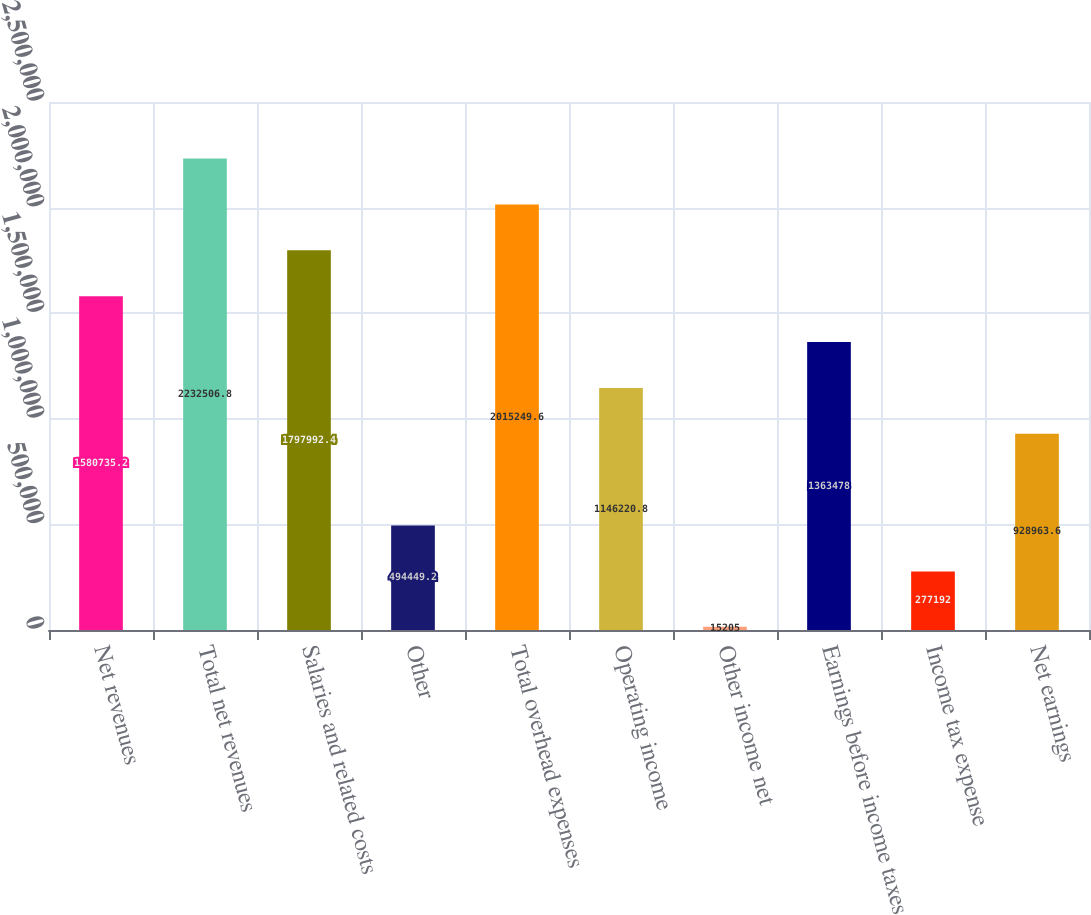Convert chart to OTSL. <chart><loc_0><loc_0><loc_500><loc_500><bar_chart><fcel>Net revenues<fcel>Total net revenues<fcel>Salaries and related costs<fcel>Other<fcel>Total overhead expenses<fcel>Operating income<fcel>Other income net<fcel>Earnings before income taxes<fcel>Income tax expense<fcel>Net earnings<nl><fcel>1.58074e+06<fcel>2.23251e+06<fcel>1.79799e+06<fcel>494449<fcel>2.01525e+06<fcel>1.14622e+06<fcel>15205<fcel>1.36348e+06<fcel>277192<fcel>928964<nl></chart> 